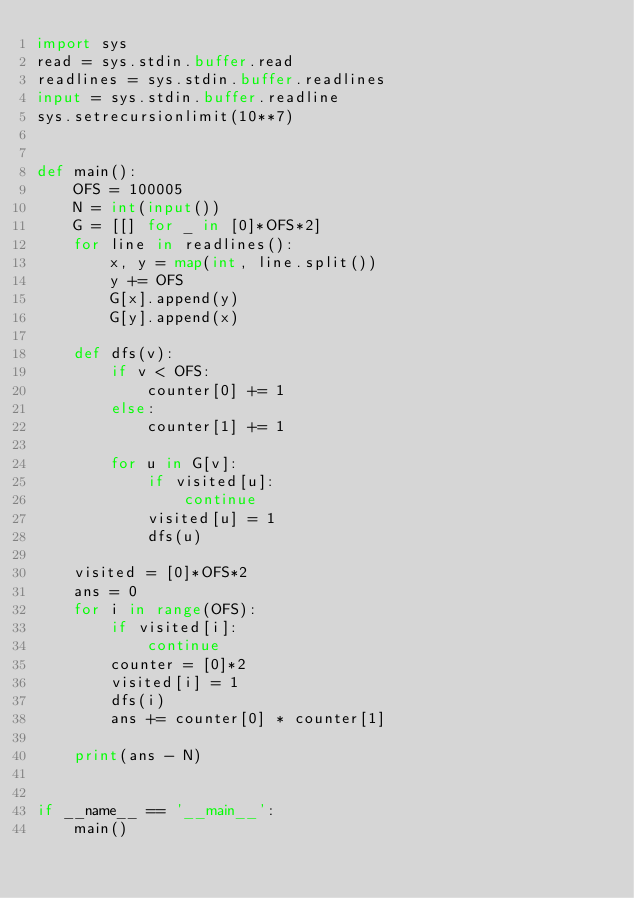<code> <loc_0><loc_0><loc_500><loc_500><_Python_>import sys
read = sys.stdin.buffer.read
readlines = sys.stdin.buffer.readlines
input = sys.stdin.buffer.readline
sys.setrecursionlimit(10**7)


def main():
    OFS = 100005
    N = int(input())
    G = [[] for _ in [0]*OFS*2]
    for line in readlines():
        x, y = map(int, line.split())
        y += OFS
        G[x].append(y)
        G[y].append(x)

    def dfs(v):
        if v < OFS:
            counter[0] += 1
        else:
            counter[1] += 1

        for u in G[v]:
            if visited[u]:
                continue
            visited[u] = 1
            dfs(u)

    visited = [0]*OFS*2
    ans = 0
    for i in range(OFS):
        if visited[i]:
            continue
        counter = [0]*2
        visited[i] = 1
        dfs(i)
        ans += counter[0] * counter[1]

    print(ans - N)


if __name__ == '__main__':
    main()</code> 